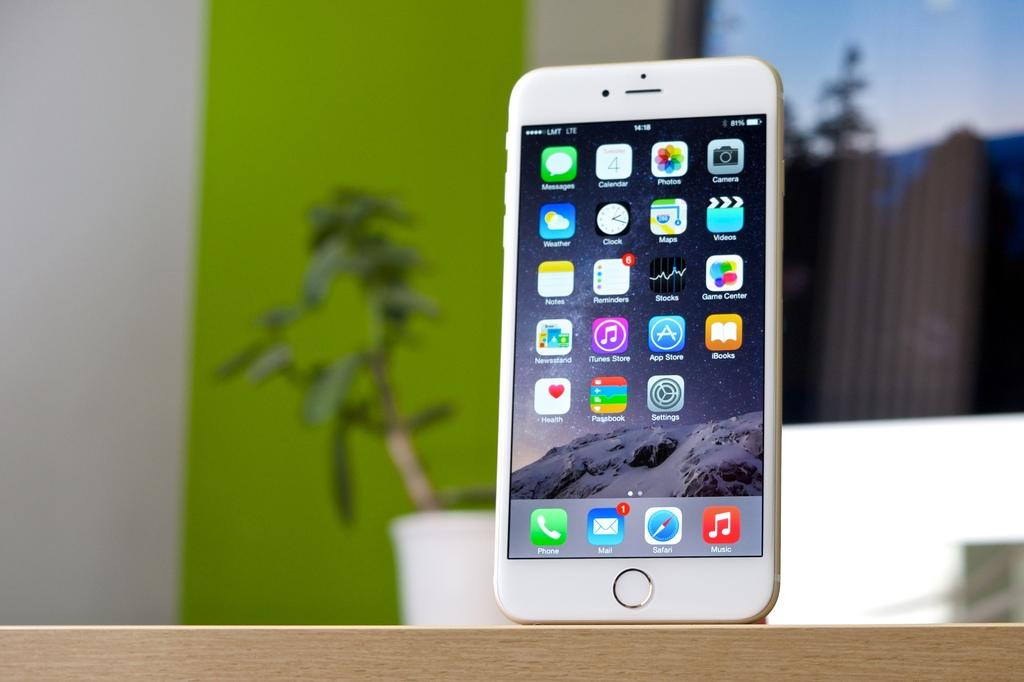<image>
Provide a brief description of the given image. Several apps such as itunes, weather, maps, and stocks, can be seen on the screen of a white iphone. 